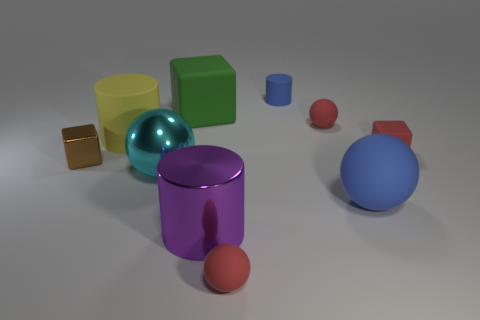Subtract all spheres. How many objects are left? 6 Add 4 small red rubber balls. How many small red rubber balls exist? 6 Subtract 0 purple spheres. How many objects are left? 10 Subtract all big metallic objects. Subtract all small red cubes. How many objects are left? 7 Add 2 blue matte cylinders. How many blue matte cylinders are left? 3 